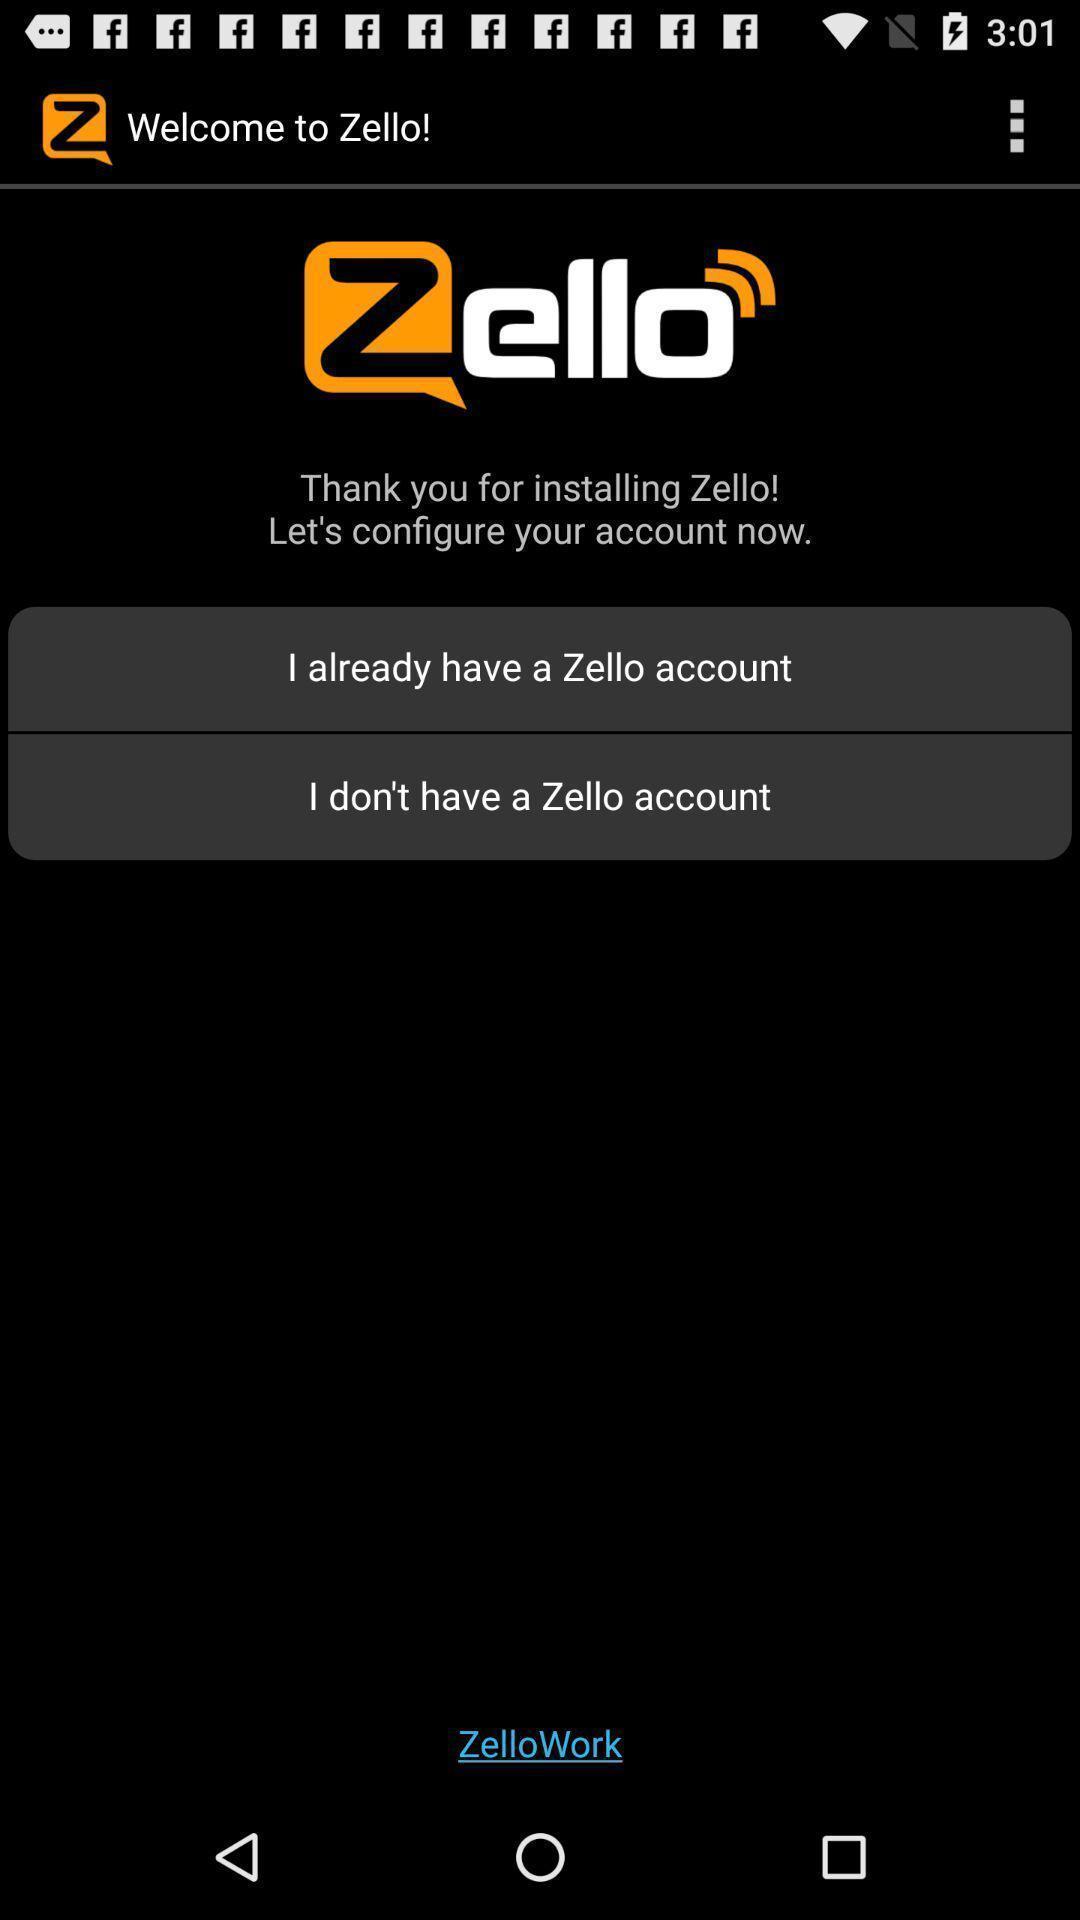Tell me what you see in this picture. Welcome page. 